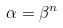Convert formula to latex. <formula><loc_0><loc_0><loc_500><loc_500>\alpha = \beta ^ { n }</formula> 